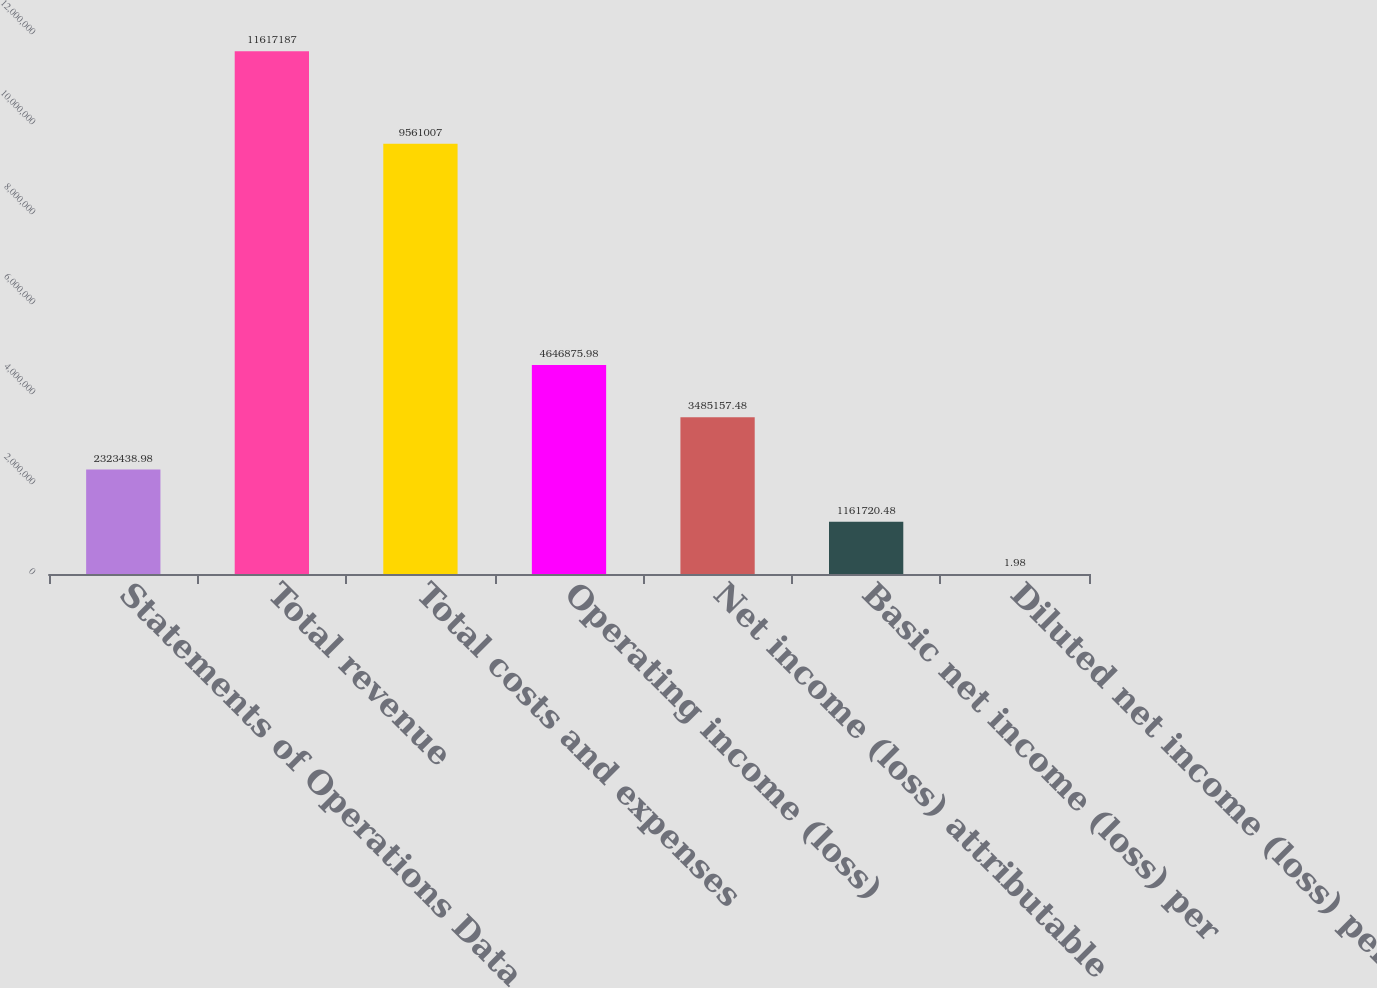Convert chart to OTSL. <chart><loc_0><loc_0><loc_500><loc_500><bar_chart><fcel>Statements of Operations Data<fcel>Total revenue<fcel>Total costs and expenses<fcel>Operating income (loss)<fcel>Net income (loss) attributable<fcel>Basic net income (loss) per<fcel>Diluted net income (loss) per<nl><fcel>2.32344e+06<fcel>1.16172e+07<fcel>9.56101e+06<fcel>4.64688e+06<fcel>3.48516e+06<fcel>1.16172e+06<fcel>1.98<nl></chart> 